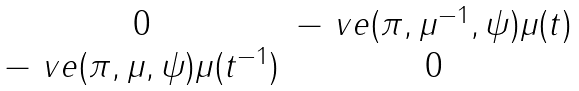<formula> <loc_0><loc_0><loc_500><loc_500>\begin{matrix} 0 & - \ v e ( \pi , \mu ^ { - 1 } , \psi ) \mu ( t ) \\ - \ v e ( \pi , \mu , \psi ) \mu ( t ^ { - 1 } ) & 0 \\ \end{matrix}</formula> 